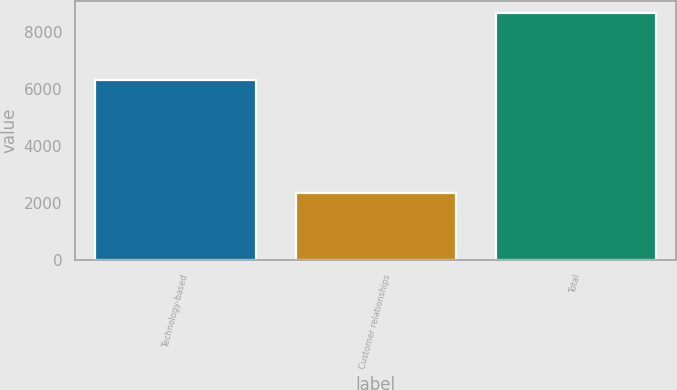<chart> <loc_0><loc_0><loc_500><loc_500><bar_chart><fcel>Technology-based<fcel>Customer relationships<fcel>Total<nl><fcel>6323<fcel>2358<fcel>8681<nl></chart> 